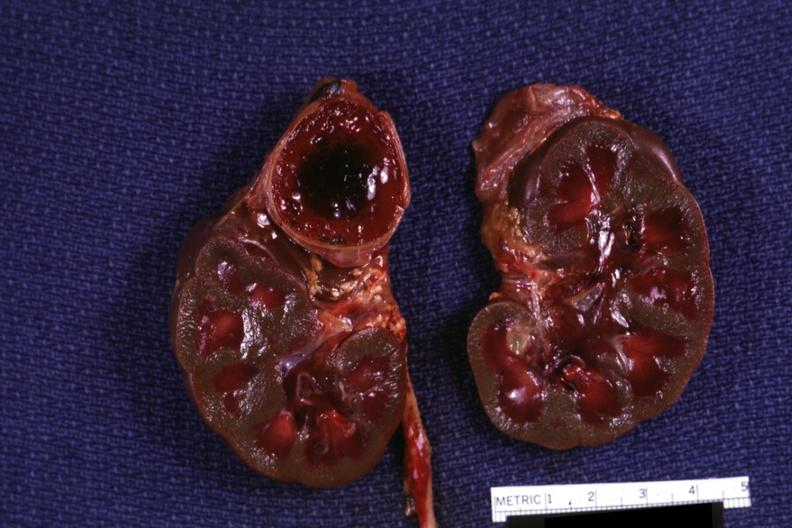where does this belong to?
Answer the question using a single word or phrase. Endocrine system 